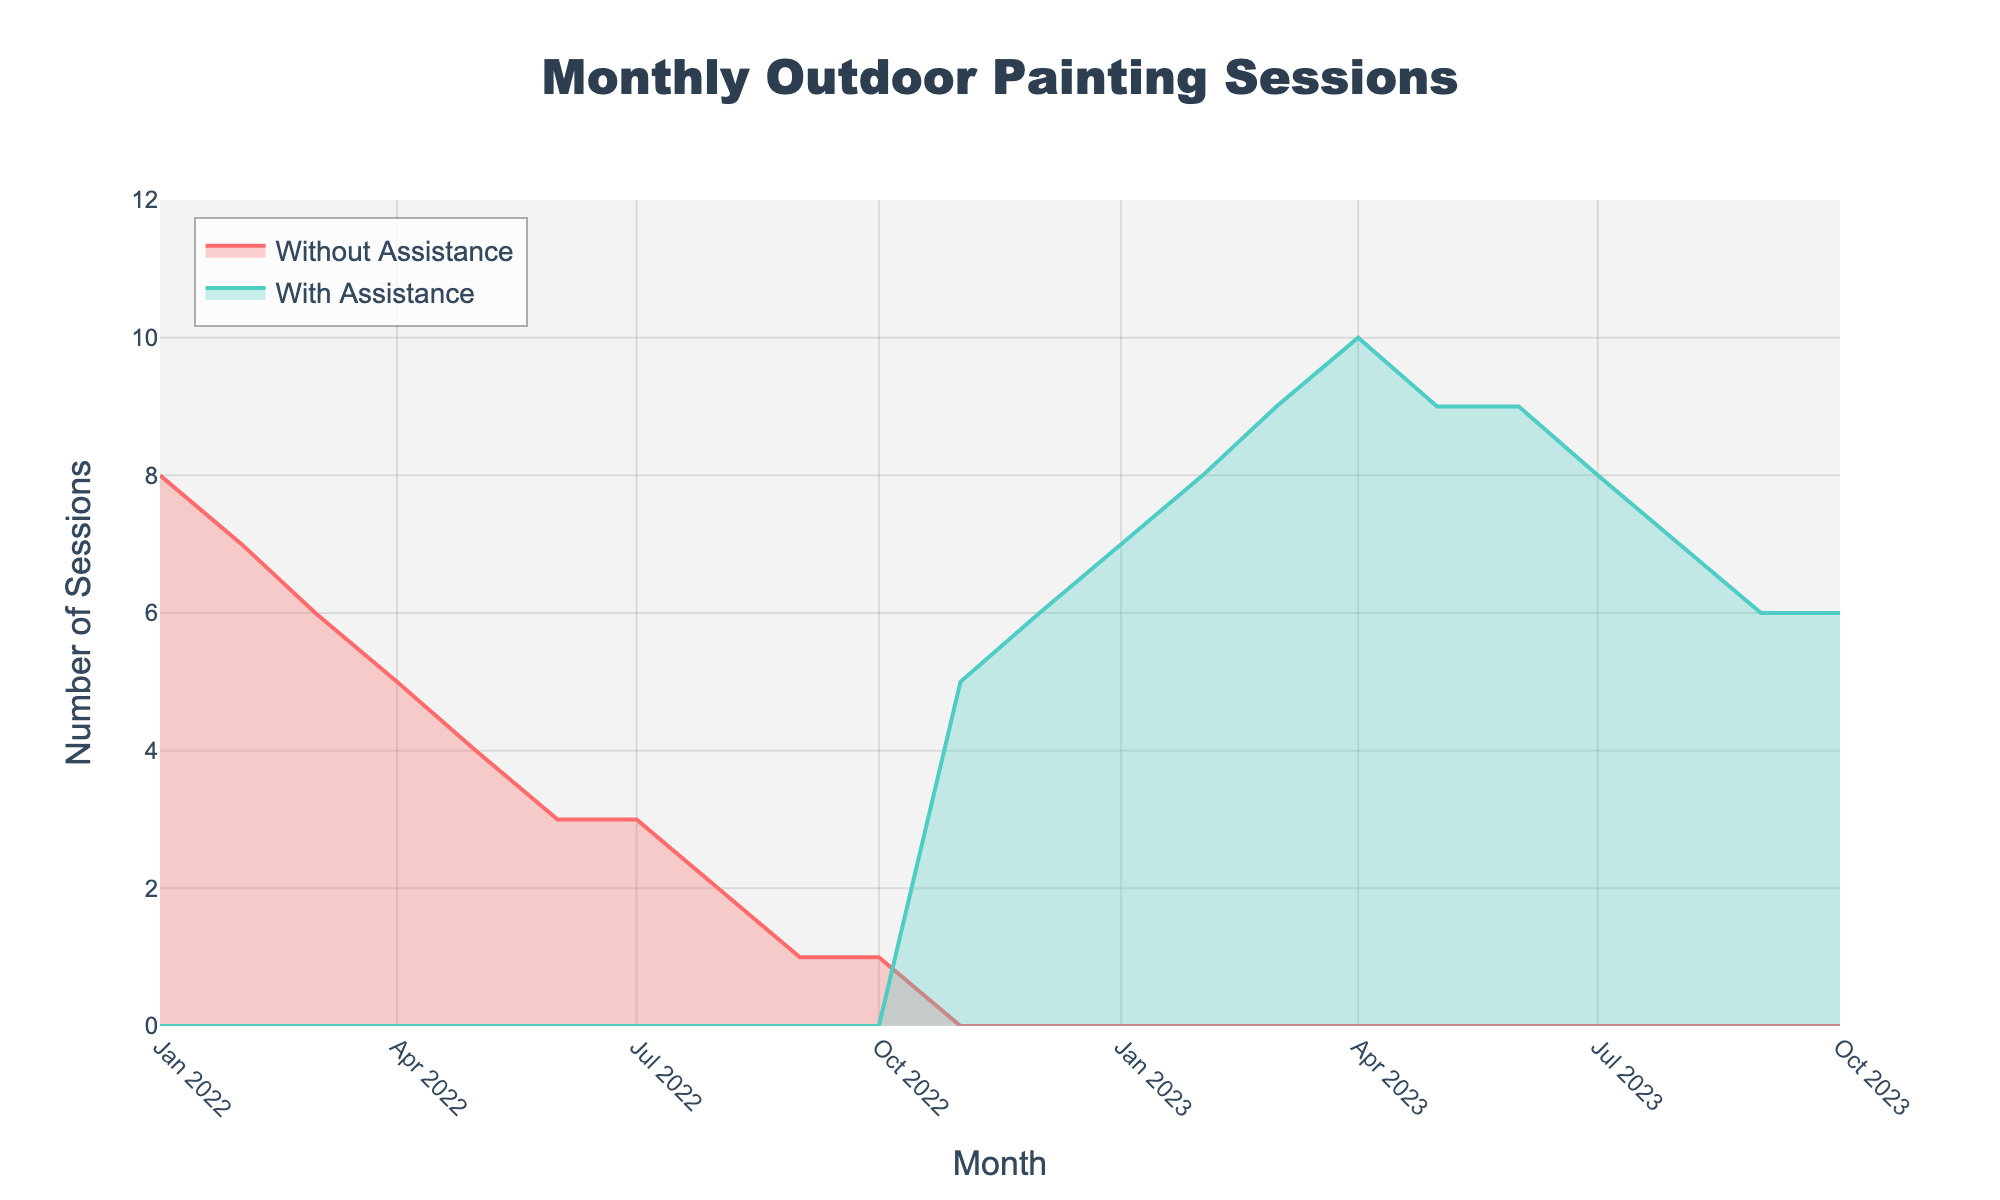What's the title of the figure? The title is usually at the top center area of a chart. It summarizes what the chart is about. In this case, the title of the figure is "Monthly Outdoor Painting Sessions".
Answer: Monthly Outdoor Painting Sessions How many months of data are shown in the figure? To determine the number of months, count each unique data point along the x-axis (representing months). The data spans from January 2022 to October 2023, inclusive.
Answer: 22 During which month did the sessions with assistance surpass the sessions without assistance? Observe the two lines on the chart and identify when the "With Assistance" line starts to have values while the "Without Assistance" line remains zero. This happens starting in November 2022.
Answer: November 2022 What is the maximum number of sessions with assistance recorded in a single month? Look at the highest point reached by the "With Assistance" line on the y-axis. This maximum value is 10 in April 2023.
Answer: 10 What was the total number of sessions without assistance from January 2022 to October 2022? Add the values of the "Without Assistance" sessions from January 2022 to October 2022 (8 + 7 + 6 + 5 + 4 + 3 + 3 + 2 + 1 + 1). The summed total is 40.
Answer: 40 Compare the number of sessions in January 2023 from both lines. Which had more, and by how much? In January 2023, "With Assistance" shows 7 sessions while "Without Assistance" shows 0. The difference is thus 7 - 0 = 7 sessions more with assistance.
Answer: 7 sessions more with assistance In which month did the "With Assistance" sessions first hold steady without increasing or decreasing? To find when the sessions with assistance held steady, look at constant values in consecutive months. This occurs from May 2023 to June 2023, where the value is 9 sessions.
Answer: May 2023 What trend do you observe in the sessions without assistance from January 2022 to October 2022? The "Without Assistance" line shows a consistent decrease in the number of sessions from January 2022 to October 2022, dropping from 8 sessions to 1 session and then to 0.
Answer: Consistent decrease During which months do the "With Assistance" sessions exhibit a decline? Examine the "With Assistance" line and note the months where the number of sessions decreases. This occurs from April 2023 to May 2023 (10 to 9) and from July 2023 to October 2023 (8 to 6).
Answer: April 2023 to May 2023, July 2023 to October 2023 What is the average number of sessions with assistance per month from November 2022 to October 2023? First, sum the number of "With Assistance" sessions from November 2022 to October 2023 (5 + 6 + 7 + 8 + 9 + 10 + 9 + 9 + 8 + 7 + 6 + 6 = 90). There are 12 months in this period. The average is 90/12 = 7.5.
Answer: 7.5 